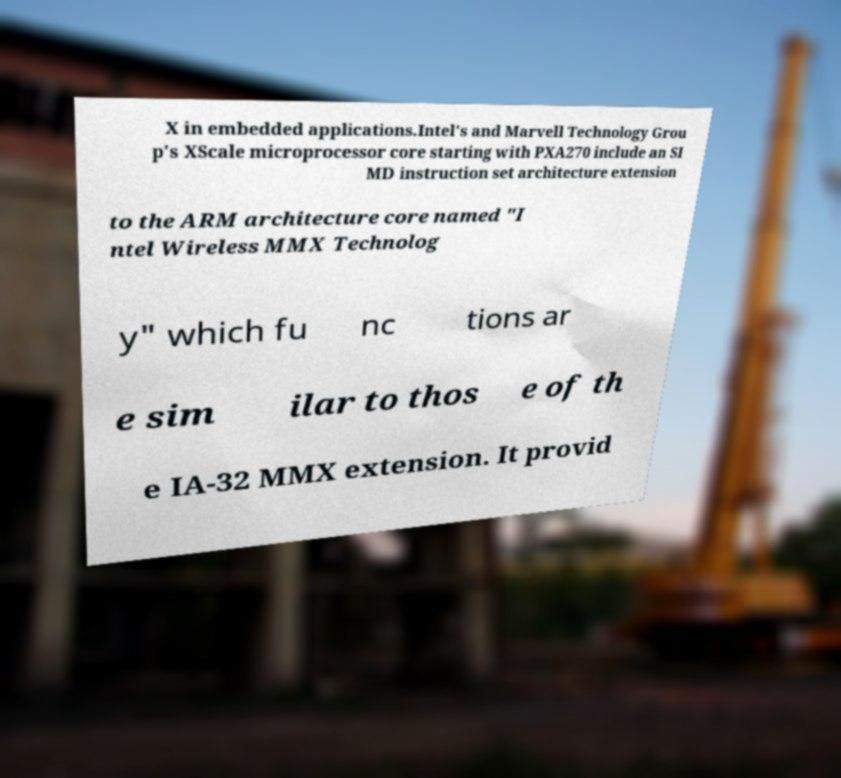There's text embedded in this image that I need extracted. Can you transcribe it verbatim? X in embedded applications.Intel's and Marvell Technology Grou p's XScale microprocessor core starting with PXA270 include an SI MD instruction set architecture extension to the ARM architecture core named "I ntel Wireless MMX Technolog y" which fu nc tions ar e sim ilar to thos e of th e IA-32 MMX extension. It provid 